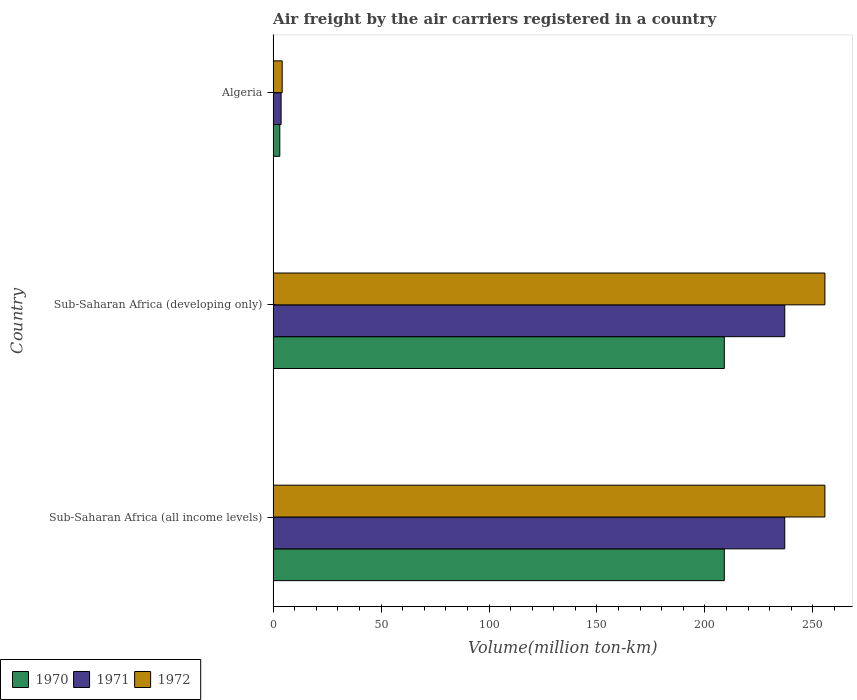Are the number of bars per tick equal to the number of legend labels?
Your answer should be very brief. Yes. How many bars are there on the 1st tick from the top?
Keep it short and to the point. 3. What is the label of the 3rd group of bars from the top?
Provide a succinct answer. Sub-Saharan Africa (all income levels). What is the volume of the air carriers in 1970 in Algeria?
Your answer should be compact. 3.1. Across all countries, what is the maximum volume of the air carriers in 1971?
Offer a terse response. 237. Across all countries, what is the minimum volume of the air carriers in 1970?
Ensure brevity in your answer.  3.1. In which country was the volume of the air carriers in 1971 maximum?
Your answer should be compact. Sub-Saharan Africa (all income levels). In which country was the volume of the air carriers in 1971 minimum?
Your answer should be very brief. Algeria. What is the total volume of the air carriers in 1972 in the graph?
Provide a succinct answer. 515.4. What is the difference between the volume of the air carriers in 1971 in Algeria and that in Sub-Saharan Africa (developing only)?
Offer a very short reply. -233.3. What is the difference between the volume of the air carriers in 1970 in Algeria and the volume of the air carriers in 1971 in Sub-Saharan Africa (all income levels)?
Offer a very short reply. -233.9. What is the average volume of the air carriers in 1971 per country?
Provide a short and direct response. 159.23. What is the difference between the volume of the air carriers in 1972 and volume of the air carriers in 1971 in Algeria?
Ensure brevity in your answer.  0.5. In how many countries, is the volume of the air carriers in 1971 greater than 120 million ton-km?
Your answer should be compact. 2. What is the ratio of the volume of the air carriers in 1972 in Sub-Saharan Africa (all income levels) to that in Sub-Saharan Africa (developing only)?
Your answer should be compact. 1. Is the volume of the air carriers in 1972 in Sub-Saharan Africa (all income levels) less than that in Sub-Saharan Africa (developing only)?
Your answer should be compact. No. Is the difference between the volume of the air carriers in 1972 in Algeria and Sub-Saharan Africa (all income levels) greater than the difference between the volume of the air carriers in 1971 in Algeria and Sub-Saharan Africa (all income levels)?
Your answer should be compact. No. What is the difference between the highest and the lowest volume of the air carriers in 1971?
Provide a short and direct response. 233.3. Is the sum of the volume of the air carriers in 1971 in Algeria and Sub-Saharan Africa (all income levels) greater than the maximum volume of the air carriers in 1970 across all countries?
Your answer should be very brief. Yes. What does the 1st bar from the top in Algeria represents?
Your response must be concise. 1972. What does the 3rd bar from the bottom in Sub-Saharan Africa (developing only) represents?
Make the answer very short. 1972. Is it the case that in every country, the sum of the volume of the air carriers in 1971 and volume of the air carriers in 1972 is greater than the volume of the air carriers in 1970?
Give a very brief answer. Yes. Are the values on the major ticks of X-axis written in scientific E-notation?
Provide a short and direct response. No. What is the title of the graph?
Your response must be concise. Air freight by the air carriers registered in a country. What is the label or title of the X-axis?
Provide a succinct answer. Volume(million ton-km). What is the Volume(million ton-km) in 1970 in Sub-Saharan Africa (all income levels)?
Provide a succinct answer. 209. What is the Volume(million ton-km) of 1971 in Sub-Saharan Africa (all income levels)?
Your answer should be compact. 237. What is the Volume(million ton-km) in 1972 in Sub-Saharan Africa (all income levels)?
Make the answer very short. 255.6. What is the Volume(million ton-km) of 1970 in Sub-Saharan Africa (developing only)?
Offer a terse response. 209. What is the Volume(million ton-km) of 1971 in Sub-Saharan Africa (developing only)?
Your response must be concise. 237. What is the Volume(million ton-km) in 1972 in Sub-Saharan Africa (developing only)?
Provide a succinct answer. 255.6. What is the Volume(million ton-km) of 1970 in Algeria?
Your answer should be compact. 3.1. What is the Volume(million ton-km) of 1971 in Algeria?
Your answer should be very brief. 3.7. What is the Volume(million ton-km) in 1972 in Algeria?
Keep it short and to the point. 4.2. Across all countries, what is the maximum Volume(million ton-km) in 1970?
Provide a short and direct response. 209. Across all countries, what is the maximum Volume(million ton-km) of 1971?
Offer a very short reply. 237. Across all countries, what is the maximum Volume(million ton-km) of 1972?
Give a very brief answer. 255.6. Across all countries, what is the minimum Volume(million ton-km) of 1970?
Offer a terse response. 3.1. Across all countries, what is the minimum Volume(million ton-km) of 1971?
Offer a terse response. 3.7. Across all countries, what is the minimum Volume(million ton-km) of 1972?
Keep it short and to the point. 4.2. What is the total Volume(million ton-km) in 1970 in the graph?
Your answer should be compact. 421.1. What is the total Volume(million ton-km) in 1971 in the graph?
Offer a very short reply. 477.7. What is the total Volume(million ton-km) in 1972 in the graph?
Provide a succinct answer. 515.4. What is the difference between the Volume(million ton-km) of 1971 in Sub-Saharan Africa (all income levels) and that in Sub-Saharan Africa (developing only)?
Your response must be concise. 0. What is the difference between the Volume(million ton-km) in 1970 in Sub-Saharan Africa (all income levels) and that in Algeria?
Your response must be concise. 205.9. What is the difference between the Volume(million ton-km) in 1971 in Sub-Saharan Africa (all income levels) and that in Algeria?
Keep it short and to the point. 233.3. What is the difference between the Volume(million ton-km) of 1972 in Sub-Saharan Africa (all income levels) and that in Algeria?
Your response must be concise. 251.4. What is the difference between the Volume(million ton-km) in 1970 in Sub-Saharan Africa (developing only) and that in Algeria?
Offer a terse response. 205.9. What is the difference between the Volume(million ton-km) in 1971 in Sub-Saharan Africa (developing only) and that in Algeria?
Ensure brevity in your answer.  233.3. What is the difference between the Volume(million ton-km) of 1972 in Sub-Saharan Africa (developing only) and that in Algeria?
Give a very brief answer. 251.4. What is the difference between the Volume(million ton-km) of 1970 in Sub-Saharan Africa (all income levels) and the Volume(million ton-km) of 1972 in Sub-Saharan Africa (developing only)?
Offer a very short reply. -46.6. What is the difference between the Volume(million ton-km) of 1971 in Sub-Saharan Africa (all income levels) and the Volume(million ton-km) of 1972 in Sub-Saharan Africa (developing only)?
Give a very brief answer. -18.6. What is the difference between the Volume(million ton-km) of 1970 in Sub-Saharan Africa (all income levels) and the Volume(million ton-km) of 1971 in Algeria?
Keep it short and to the point. 205.3. What is the difference between the Volume(million ton-km) in 1970 in Sub-Saharan Africa (all income levels) and the Volume(million ton-km) in 1972 in Algeria?
Your answer should be compact. 204.8. What is the difference between the Volume(million ton-km) of 1971 in Sub-Saharan Africa (all income levels) and the Volume(million ton-km) of 1972 in Algeria?
Offer a terse response. 232.8. What is the difference between the Volume(million ton-km) in 1970 in Sub-Saharan Africa (developing only) and the Volume(million ton-km) in 1971 in Algeria?
Your answer should be compact. 205.3. What is the difference between the Volume(million ton-km) in 1970 in Sub-Saharan Africa (developing only) and the Volume(million ton-km) in 1972 in Algeria?
Keep it short and to the point. 204.8. What is the difference between the Volume(million ton-km) in 1971 in Sub-Saharan Africa (developing only) and the Volume(million ton-km) in 1972 in Algeria?
Your response must be concise. 232.8. What is the average Volume(million ton-km) in 1970 per country?
Offer a terse response. 140.37. What is the average Volume(million ton-km) in 1971 per country?
Offer a very short reply. 159.23. What is the average Volume(million ton-km) of 1972 per country?
Your response must be concise. 171.8. What is the difference between the Volume(million ton-km) of 1970 and Volume(million ton-km) of 1972 in Sub-Saharan Africa (all income levels)?
Offer a terse response. -46.6. What is the difference between the Volume(million ton-km) in 1971 and Volume(million ton-km) in 1972 in Sub-Saharan Africa (all income levels)?
Ensure brevity in your answer.  -18.6. What is the difference between the Volume(million ton-km) of 1970 and Volume(million ton-km) of 1972 in Sub-Saharan Africa (developing only)?
Offer a very short reply. -46.6. What is the difference between the Volume(million ton-km) in 1971 and Volume(million ton-km) in 1972 in Sub-Saharan Africa (developing only)?
Offer a very short reply. -18.6. What is the difference between the Volume(million ton-km) of 1971 and Volume(million ton-km) of 1972 in Algeria?
Your answer should be very brief. -0.5. What is the ratio of the Volume(million ton-km) in 1971 in Sub-Saharan Africa (all income levels) to that in Sub-Saharan Africa (developing only)?
Make the answer very short. 1. What is the ratio of the Volume(million ton-km) of 1970 in Sub-Saharan Africa (all income levels) to that in Algeria?
Offer a terse response. 67.42. What is the ratio of the Volume(million ton-km) in 1971 in Sub-Saharan Africa (all income levels) to that in Algeria?
Ensure brevity in your answer.  64.05. What is the ratio of the Volume(million ton-km) of 1972 in Sub-Saharan Africa (all income levels) to that in Algeria?
Provide a succinct answer. 60.86. What is the ratio of the Volume(million ton-km) in 1970 in Sub-Saharan Africa (developing only) to that in Algeria?
Your answer should be compact. 67.42. What is the ratio of the Volume(million ton-km) in 1971 in Sub-Saharan Africa (developing only) to that in Algeria?
Your answer should be very brief. 64.05. What is the ratio of the Volume(million ton-km) of 1972 in Sub-Saharan Africa (developing only) to that in Algeria?
Keep it short and to the point. 60.86. What is the difference between the highest and the second highest Volume(million ton-km) of 1970?
Ensure brevity in your answer.  0. What is the difference between the highest and the second highest Volume(million ton-km) in 1971?
Your response must be concise. 0. What is the difference between the highest and the second highest Volume(million ton-km) of 1972?
Give a very brief answer. 0. What is the difference between the highest and the lowest Volume(million ton-km) of 1970?
Make the answer very short. 205.9. What is the difference between the highest and the lowest Volume(million ton-km) of 1971?
Your response must be concise. 233.3. What is the difference between the highest and the lowest Volume(million ton-km) in 1972?
Offer a terse response. 251.4. 